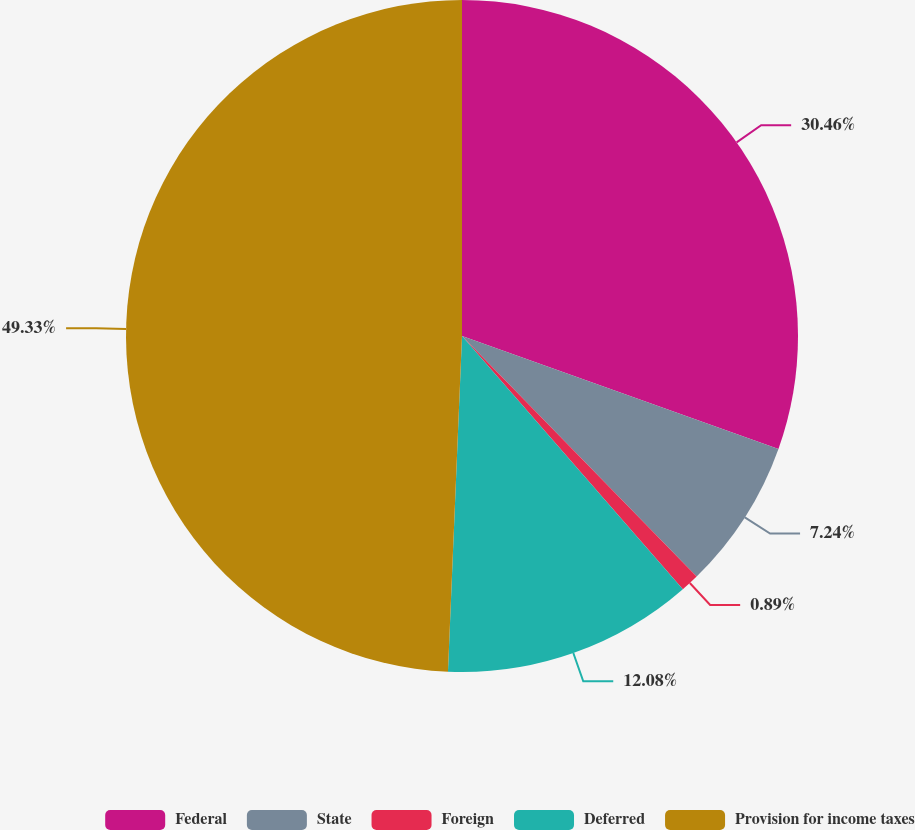Convert chart. <chart><loc_0><loc_0><loc_500><loc_500><pie_chart><fcel>Federal<fcel>State<fcel>Foreign<fcel>Deferred<fcel>Provision for income taxes<nl><fcel>30.46%<fcel>7.24%<fcel>0.89%<fcel>12.08%<fcel>49.34%<nl></chart> 